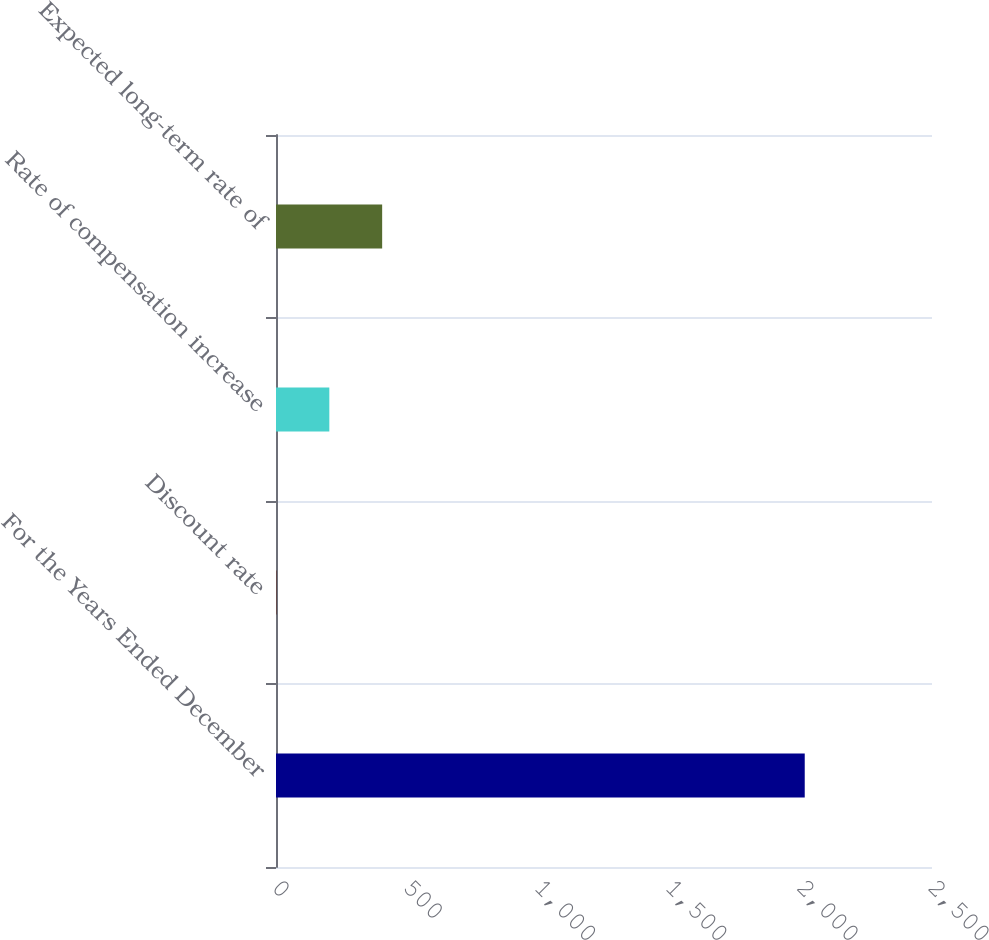<chart> <loc_0><loc_0><loc_500><loc_500><bar_chart><fcel>For the Years Ended December<fcel>Discount rate<fcel>Rate of compensation increase<fcel>Expected long-term rate of<nl><fcel>2015<fcel>1.94<fcel>203.25<fcel>404.56<nl></chart> 